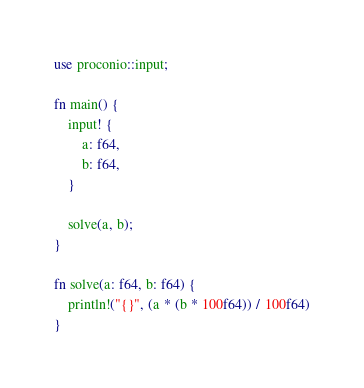Convert code to text. <code><loc_0><loc_0><loc_500><loc_500><_Rust_>use proconio::input;

fn main() {
    input! {
        a: f64,
        b: f64,
    }

    solve(a, b);
}

fn solve(a: f64, b: f64) {
    println!("{}", (a * (b * 100f64)) / 100f64)
}
</code> 